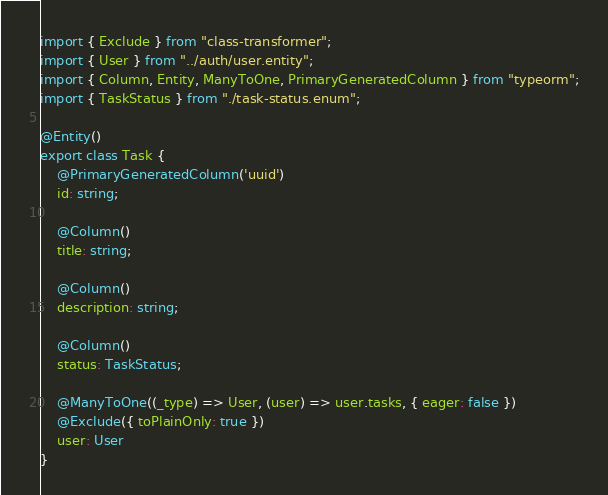Convert code to text. <code><loc_0><loc_0><loc_500><loc_500><_TypeScript_>import { Exclude } from "class-transformer";
import { User } from "../auth/user.entity";
import { Column, Entity, ManyToOne, PrimaryGeneratedColumn } from "typeorm";
import { TaskStatus } from "./task-status.enum";

@Entity()
export class Task {
    @PrimaryGeneratedColumn('uuid')
    id: string;

    @Column()
    title: string;

    @Column()
    description: string;

    @Column()
    status: TaskStatus;

    @ManyToOne((_type) => User, (user) => user.tasks, { eager: false })
    @Exclude({ toPlainOnly: true })
    user: User
}</code> 